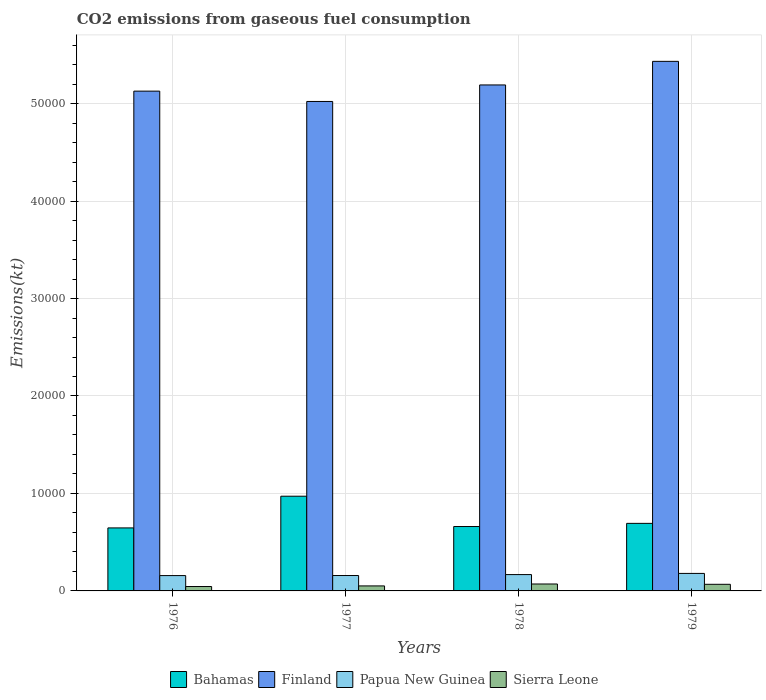How many different coloured bars are there?
Your answer should be very brief. 4. How many groups of bars are there?
Make the answer very short. 4. Are the number of bars per tick equal to the number of legend labels?
Your answer should be compact. Yes. Are the number of bars on each tick of the X-axis equal?
Offer a terse response. Yes. How many bars are there on the 2nd tick from the right?
Keep it short and to the point. 4. In how many cases, is the number of bars for a given year not equal to the number of legend labels?
Provide a short and direct response. 0. What is the amount of CO2 emitted in Bahamas in 1977?
Make the answer very short. 9717.55. Across all years, what is the maximum amount of CO2 emitted in Bahamas?
Your response must be concise. 9717.55. Across all years, what is the minimum amount of CO2 emitted in Finland?
Your answer should be compact. 5.02e+04. In which year was the amount of CO2 emitted in Papua New Guinea maximum?
Offer a terse response. 1979. In which year was the amount of CO2 emitted in Finland minimum?
Give a very brief answer. 1977. What is the total amount of CO2 emitted in Sierra Leone in the graph?
Ensure brevity in your answer.  2354.21. What is the difference between the amount of CO2 emitted in Bahamas in 1977 and that in 1979?
Your answer should be compact. 2786.92. What is the difference between the amount of CO2 emitted in Bahamas in 1977 and the amount of CO2 emitted in Papua New Guinea in 1979?
Provide a short and direct response. 7920.72. What is the average amount of CO2 emitted in Sierra Leone per year?
Keep it short and to the point. 588.55. In the year 1977, what is the difference between the amount of CO2 emitted in Papua New Guinea and amount of CO2 emitted in Sierra Leone?
Offer a very short reply. 1067.1. In how many years, is the amount of CO2 emitted in Bahamas greater than 6000 kt?
Provide a short and direct response. 4. What is the ratio of the amount of CO2 emitted in Papua New Guinea in 1976 to that in 1979?
Your response must be concise. 0.88. Is the amount of CO2 emitted in Bahamas in 1976 less than that in 1979?
Give a very brief answer. Yes. Is the difference between the amount of CO2 emitted in Papua New Guinea in 1976 and 1979 greater than the difference between the amount of CO2 emitted in Sierra Leone in 1976 and 1979?
Provide a short and direct response. Yes. What is the difference between the highest and the second highest amount of CO2 emitted in Bahamas?
Give a very brief answer. 2786.92. What is the difference between the highest and the lowest amount of CO2 emitted in Finland?
Your response must be concise. 4114.37. Is the sum of the amount of CO2 emitted in Bahamas in 1976 and 1978 greater than the maximum amount of CO2 emitted in Papua New Guinea across all years?
Keep it short and to the point. Yes. Is it the case that in every year, the sum of the amount of CO2 emitted in Finland and amount of CO2 emitted in Papua New Guinea is greater than the sum of amount of CO2 emitted in Sierra Leone and amount of CO2 emitted in Bahamas?
Make the answer very short. Yes. What does the 4th bar from the left in 1978 represents?
Keep it short and to the point. Sierra Leone. What does the 1st bar from the right in 1976 represents?
Offer a terse response. Sierra Leone. What is the difference between two consecutive major ticks on the Y-axis?
Your answer should be very brief. 10000. Are the values on the major ticks of Y-axis written in scientific E-notation?
Keep it short and to the point. No. Does the graph contain any zero values?
Offer a very short reply. No. Where does the legend appear in the graph?
Provide a succinct answer. Bottom center. What is the title of the graph?
Offer a terse response. CO2 emissions from gaseous fuel consumption. Does "Venezuela" appear as one of the legend labels in the graph?
Keep it short and to the point. No. What is the label or title of the X-axis?
Your answer should be very brief. Years. What is the label or title of the Y-axis?
Keep it short and to the point. Emissions(kt). What is the Emissions(kt) in Bahamas in 1976?
Provide a succinct answer. 6464.92. What is the Emissions(kt) in Finland in 1976?
Your answer should be compact. 5.13e+04. What is the Emissions(kt) in Papua New Guinea in 1976?
Provide a short and direct response. 1573.14. What is the Emissions(kt) in Sierra Leone in 1976?
Your response must be concise. 451.04. What is the Emissions(kt) of Bahamas in 1977?
Give a very brief answer. 9717.55. What is the Emissions(kt) of Finland in 1977?
Your response must be concise. 5.02e+04. What is the Emissions(kt) in Papua New Guinea in 1977?
Offer a very short reply. 1580.48. What is the Emissions(kt) of Sierra Leone in 1977?
Give a very brief answer. 513.38. What is the Emissions(kt) of Bahamas in 1978?
Your answer should be very brief. 6607.93. What is the Emissions(kt) of Finland in 1978?
Offer a very short reply. 5.19e+04. What is the Emissions(kt) of Papua New Guinea in 1978?
Offer a terse response. 1675.82. What is the Emissions(kt) in Sierra Leone in 1978?
Provide a succinct answer. 711.4. What is the Emissions(kt) in Bahamas in 1979?
Provide a short and direct response. 6930.63. What is the Emissions(kt) in Finland in 1979?
Your answer should be very brief. 5.43e+04. What is the Emissions(kt) of Papua New Guinea in 1979?
Your answer should be very brief. 1796.83. What is the Emissions(kt) of Sierra Leone in 1979?
Your answer should be very brief. 678.39. Across all years, what is the maximum Emissions(kt) in Bahamas?
Your answer should be very brief. 9717.55. Across all years, what is the maximum Emissions(kt) in Finland?
Provide a succinct answer. 5.43e+04. Across all years, what is the maximum Emissions(kt) in Papua New Guinea?
Your answer should be compact. 1796.83. Across all years, what is the maximum Emissions(kt) of Sierra Leone?
Provide a short and direct response. 711.4. Across all years, what is the minimum Emissions(kt) in Bahamas?
Your response must be concise. 6464.92. Across all years, what is the minimum Emissions(kt) in Finland?
Give a very brief answer. 5.02e+04. Across all years, what is the minimum Emissions(kt) of Papua New Guinea?
Keep it short and to the point. 1573.14. Across all years, what is the minimum Emissions(kt) of Sierra Leone?
Make the answer very short. 451.04. What is the total Emissions(kt) of Bahamas in the graph?
Provide a short and direct response. 2.97e+04. What is the total Emissions(kt) in Finland in the graph?
Your answer should be very brief. 2.08e+05. What is the total Emissions(kt) in Papua New Guinea in the graph?
Keep it short and to the point. 6626.27. What is the total Emissions(kt) in Sierra Leone in the graph?
Your answer should be compact. 2354.21. What is the difference between the Emissions(kt) of Bahamas in 1976 and that in 1977?
Provide a succinct answer. -3252.63. What is the difference between the Emissions(kt) in Finland in 1976 and that in 1977?
Make the answer very short. 1059.76. What is the difference between the Emissions(kt) in Papua New Guinea in 1976 and that in 1977?
Offer a terse response. -7.33. What is the difference between the Emissions(kt) in Sierra Leone in 1976 and that in 1977?
Keep it short and to the point. -62.34. What is the difference between the Emissions(kt) of Bahamas in 1976 and that in 1978?
Make the answer very short. -143.01. What is the difference between the Emissions(kt) of Finland in 1976 and that in 1978?
Provide a succinct answer. -634.39. What is the difference between the Emissions(kt) in Papua New Guinea in 1976 and that in 1978?
Ensure brevity in your answer.  -102.68. What is the difference between the Emissions(kt) of Sierra Leone in 1976 and that in 1978?
Ensure brevity in your answer.  -260.36. What is the difference between the Emissions(kt) of Bahamas in 1976 and that in 1979?
Provide a succinct answer. -465.71. What is the difference between the Emissions(kt) of Finland in 1976 and that in 1979?
Your answer should be very brief. -3054.61. What is the difference between the Emissions(kt) in Papua New Guinea in 1976 and that in 1979?
Provide a short and direct response. -223.69. What is the difference between the Emissions(kt) of Sierra Leone in 1976 and that in 1979?
Provide a short and direct response. -227.35. What is the difference between the Emissions(kt) of Bahamas in 1977 and that in 1978?
Make the answer very short. 3109.62. What is the difference between the Emissions(kt) in Finland in 1977 and that in 1978?
Your response must be concise. -1694.15. What is the difference between the Emissions(kt) in Papua New Guinea in 1977 and that in 1978?
Your answer should be very brief. -95.34. What is the difference between the Emissions(kt) of Sierra Leone in 1977 and that in 1978?
Your answer should be compact. -198.02. What is the difference between the Emissions(kt) in Bahamas in 1977 and that in 1979?
Your answer should be very brief. 2786.92. What is the difference between the Emissions(kt) of Finland in 1977 and that in 1979?
Make the answer very short. -4114.37. What is the difference between the Emissions(kt) in Papua New Guinea in 1977 and that in 1979?
Ensure brevity in your answer.  -216.35. What is the difference between the Emissions(kt) in Sierra Leone in 1977 and that in 1979?
Provide a succinct answer. -165.01. What is the difference between the Emissions(kt) in Bahamas in 1978 and that in 1979?
Keep it short and to the point. -322.7. What is the difference between the Emissions(kt) in Finland in 1978 and that in 1979?
Offer a terse response. -2420.22. What is the difference between the Emissions(kt) of Papua New Guinea in 1978 and that in 1979?
Offer a very short reply. -121.01. What is the difference between the Emissions(kt) in Sierra Leone in 1978 and that in 1979?
Keep it short and to the point. 33. What is the difference between the Emissions(kt) in Bahamas in 1976 and the Emissions(kt) in Finland in 1977?
Offer a terse response. -4.38e+04. What is the difference between the Emissions(kt) in Bahamas in 1976 and the Emissions(kt) in Papua New Guinea in 1977?
Keep it short and to the point. 4884.44. What is the difference between the Emissions(kt) of Bahamas in 1976 and the Emissions(kt) of Sierra Leone in 1977?
Provide a succinct answer. 5951.54. What is the difference between the Emissions(kt) in Finland in 1976 and the Emissions(kt) in Papua New Guinea in 1977?
Your answer should be very brief. 4.97e+04. What is the difference between the Emissions(kt) in Finland in 1976 and the Emissions(kt) in Sierra Leone in 1977?
Provide a short and direct response. 5.08e+04. What is the difference between the Emissions(kt) in Papua New Guinea in 1976 and the Emissions(kt) in Sierra Leone in 1977?
Give a very brief answer. 1059.76. What is the difference between the Emissions(kt) in Bahamas in 1976 and the Emissions(kt) in Finland in 1978?
Provide a succinct answer. -4.54e+04. What is the difference between the Emissions(kt) in Bahamas in 1976 and the Emissions(kt) in Papua New Guinea in 1978?
Your response must be concise. 4789.1. What is the difference between the Emissions(kt) in Bahamas in 1976 and the Emissions(kt) in Sierra Leone in 1978?
Give a very brief answer. 5753.52. What is the difference between the Emissions(kt) of Finland in 1976 and the Emissions(kt) of Papua New Guinea in 1978?
Provide a succinct answer. 4.96e+04. What is the difference between the Emissions(kt) in Finland in 1976 and the Emissions(kt) in Sierra Leone in 1978?
Provide a succinct answer. 5.06e+04. What is the difference between the Emissions(kt) in Papua New Guinea in 1976 and the Emissions(kt) in Sierra Leone in 1978?
Offer a very short reply. 861.75. What is the difference between the Emissions(kt) of Bahamas in 1976 and the Emissions(kt) of Finland in 1979?
Offer a very short reply. -4.79e+04. What is the difference between the Emissions(kt) in Bahamas in 1976 and the Emissions(kt) in Papua New Guinea in 1979?
Provide a succinct answer. 4668.09. What is the difference between the Emissions(kt) of Bahamas in 1976 and the Emissions(kt) of Sierra Leone in 1979?
Offer a very short reply. 5786.53. What is the difference between the Emissions(kt) of Finland in 1976 and the Emissions(kt) of Papua New Guinea in 1979?
Offer a terse response. 4.95e+04. What is the difference between the Emissions(kt) in Finland in 1976 and the Emissions(kt) in Sierra Leone in 1979?
Offer a very short reply. 5.06e+04. What is the difference between the Emissions(kt) in Papua New Guinea in 1976 and the Emissions(kt) in Sierra Leone in 1979?
Give a very brief answer. 894.75. What is the difference between the Emissions(kt) of Bahamas in 1977 and the Emissions(kt) of Finland in 1978?
Your answer should be compact. -4.22e+04. What is the difference between the Emissions(kt) in Bahamas in 1977 and the Emissions(kt) in Papua New Guinea in 1978?
Provide a short and direct response. 8041.73. What is the difference between the Emissions(kt) of Bahamas in 1977 and the Emissions(kt) of Sierra Leone in 1978?
Your response must be concise. 9006.15. What is the difference between the Emissions(kt) of Finland in 1977 and the Emissions(kt) of Papua New Guinea in 1978?
Offer a terse response. 4.85e+04. What is the difference between the Emissions(kt) of Finland in 1977 and the Emissions(kt) of Sierra Leone in 1978?
Your answer should be very brief. 4.95e+04. What is the difference between the Emissions(kt) in Papua New Guinea in 1977 and the Emissions(kt) in Sierra Leone in 1978?
Your response must be concise. 869.08. What is the difference between the Emissions(kt) of Bahamas in 1977 and the Emissions(kt) of Finland in 1979?
Give a very brief answer. -4.46e+04. What is the difference between the Emissions(kt) in Bahamas in 1977 and the Emissions(kt) in Papua New Guinea in 1979?
Your response must be concise. 7920.72. What is the difference between the Emissions(kt) of Bahamas in 1977 and the Emissions(kt) of Sierra Leone in 1979?
Your answer should be compact. 9039.16. What is the difference between the Emissions(kt) of Finland in 1977 and the Emissions(kt) of Papua New Guinea in 1979?
Give a very brief answer. 4.84e+04. What is the difference between the Emissions(kt) of Finland in 1977 and the Emissions(kt) of Sierra Leone in 1979?
Your answer should be compact. 4.95e+04. What is the difference between the Emissions(kt) in Papua New Guinea in 1977 and the Emissions(kt) in Sierra Leone in 1979?
Your answer should be compact. 902.08. What is the difference between the Emissions(kt) of Bahamas in 1978 and the Emissions(kt) of Finland in 1979?
Offer a terse response. -4.77e+04. What is the difference between the Emissions(kt) of Bahamas in 1978 and the Emissions(kt) of Papua New Guinea in 1979?
Your response must be concise. 4811.1. What is the difference between the Emissions(kt) in Bahamas in 1978 and the Emissions(kt) in Sierra Leone in 1979?
Your response must be concise. 5929.54. What is the difference between the Emissions(kt) of Finland in 1978 and the Emissions(kt) of Papua New Guinea in 1979?
Offer a terse response. 5.01e+04. What is the difference between the Emissions(kt) of Finland in 1978 and the Emissions(kt) of Sierra Leone in 1979?
Offer a very short reply. 5.12e+04. What is the difference between the Emissions(kt) of Papua New Guinea in 1978 and the Emissions(kt) of Sierra Leone in 1979?
Your response must be concise. 997.42. What is the average Emissions(kt) of Bahamas per year?
Offer a terse response. 7430.26. What is the average Emissions(kt) of Finland per year?
Make the answer very short. 5.19e+04. What is the average Emissions(kt) of Papua New Guinea per year?
Your answer should be compact. 1656.57. What is the average Emissions(kt) of Sierra Leone per year?
Your answer should be very brief. 588.55. In the year 1976, what is the difference between the Emissions(kt) of Bahamas and Emissions(kt) of Finland?
Offer a terse response. -4.48e+04. In the year 1976, what is the difference between the Emissions(kt) in Bahamas and Emissions(kt) in Papua New Guinea?
Ensure brevity in your answer.  4891.78. In the year 1976, what is the difference between the Emissions(kt) in Bahamas and Emissions(kt) in Sierra Leone?
Your answer should be very brief. 6013.88. In the year 1976, what is the difference between the Emissions(kt) of Finland and Emissions(kt) of Papua New Guinea?
Your answer should be compact. 4.97e+04. In the year 1976, what is the difference between the Emissions(kt) of Finland and Emissions(kt) of Sierra Leone?
Your response must be concise. 5.08e+04. In the year 1976, what is the difference between the Emissions(kt) in Papua New Guinea and Emissions(kt) in Sierra Leone?
Keep it short and to the point. 1122.1. In the year 1977, what is the difference between the Emissions(kt) of Bahamas and Emissions(kt) of Finland?
Your answer should be very brief. -4.05e+04. In the year 1977, what is the difference between the Emissions(kt) of Bahamas and Emissions(kt) of Papua New Guinea?
Make the answer very short. 8137.07. In the year 1977, what is the difference between the Emissions(kt) in Bahamas and Emissions(kt) in Sierra Leone?
Your answer should be compact. 9204.17. In the year 1977, what is the difference between the Emissions(kt) of Finland and Emissions(kt) of Papua New Guinea?
Keep it short and to the point. 4.86e+04. In the year 1977, what is the difference between the Emissions(kt) in Finland and Emissions(kt) in Sierra Leone?
Provide a succinct answer. 4.97e+04. In the year 1977, what is the difference between the Emissions(kt) of Papua New Guinea and Emissions(kt) of Sierra Leone?
Ensure brevity in your answer.  1067.1. In the year 1978, what is the difference between the Emissions(kt) of Bahamas and Emissions(kt) of Finland?
Give a very brief answer. -4.53e+04. In the year 1978, what is the difference between the Emissions(kt) in Bahamas and Emissions(kt) in Papua New Guinea?
Your answer should be compact. 4932.11. In the year 1978, what is the difference between the Emissions(kt) in Bahamas and Emissions(kt) in Sierra Leone?
Make the answer very short. 5896.54. In the year 1978, what is the difference between the Emissions(kt) in Finland and Emissions(kt) in Papua New Guinea?
Keep it short and to the point. 5.02e+04. In the year 1978, what is the difference between the Emissions(kt) in Finland and Emissions(kt) in Sierra Leone?
Your answer should be compact. 5.12e+04. In the year 1978, what is the difference between the Emissions(kt) in Papua New Guinea and Emissions(kt) in Sierra Leone?
Offer a very short reply. 964.42. In the year 1979, what is the difference between the Emissions(kt) in Bahamas and Emissions(kt) in Finland?
Offer a very short reply. -4.74e+04. In the year 1979, what is the difference between the Emissions(kt) of Bahamas and Emissions(kt) of Papua New Guinea?
Make the answer very short. 5133.8. In the year 1979, what is the difference between the Emissions(kt) of Bahamas and Emissions(kt) of Sierra Leone?
Your response must be concise. 6252.23. In the year 1979, what is the difference between the Emissions(kt) of Finland and Emissions(kt) of Papua New Guinea?
Make the answer very short. 5.25e+04. In the year 1979, what is the difference between the Emissions(kt) of Finland and Emissions(kt) of Sierra Leone?
Your answer should be very brief. 5.37e+04. In the year 1979, what is the difference between the Emissions(kt) of Papua New Guinea and Emissions(kt) of Sierra Leone?
Ensure brevity in your answer.  1118.43. What is the ratio of the Emissions(kt) in Bahamas in 1976 to that in 1977?
Offer a terse response. 0.67. What is the ratio of the Emissions(kt) of Finland in 1976 to that in 1977?
Provide a succinct answer. 1.02. What is the ratio of the Emissions(kt) of Papua New Guinea in 1976 to that in 1977?
Provide a succinct answer. 1. What is the ratio of the Emissions(kt) of Sierra Leone in 1976 to that in 1977?
Offer a terse response. 0.88. What is the ratio of the Emissions(kt) of Bahamas in 1976 to that in 1978?
Offer a terse response. 0.98. What is the ratio of the Emissions(kt) in Papua New Guinea in 1976 to that in 1978?
Provide a short and direct response. 0.94. What is the ratio of the Emissions(kt) of Sierra Leone in 1976 to that in 1978?
Offer a terse response. 0.63. What is the ratio of the Emissions(kt) of Bahamas in 1976 to that in 1979?
Make the answer very short. 0.93. What is the ratio of the Emissions(kt) of Finland in 1976 to that in 1979?
Your answer should be compact. 0.94. What is the ratio of the Emissions(kt) in Papua New Guinea in 1976 to that in 1979?
Provide a short and direct response. 0.88. What is the ratio of the Emissions(kt) in Sierra Leone in 1976 to that in 1979?
Offer a very short reply. 0.66. What is the ratio of the Emissions(kt) of Bahamas in 1977 to that in 1978?
Your response must be concise. 1.47. What is the ratio of the Emissions(kt) of Finland in 1977 to that in 1978?
Keep it short and to the point. 0.97. What is the ratio of the Emissions(kt) of Papua New Guinea in 1977 to that in 1978?
Provide a succinct answer. 0.94. What is the ratio of the Emissions(kt) of Sierra Leone in 1977 to that in 1978?
Offer a very short reply. 0.72. What is the ratio of the Emissions(kt) in Bahamas in 1977 to that in 1979?
Your response must be concise. 1.4. What is the ratio of the Emissions(kt) of Finland in 1977 to that in 1979?
Offer a terse response. 0.92. What is the ratio of the Emissions(kt) of Papua New Guinea in 1977 to that in 1979?
Give a very brief answer. 0.88. What is the ratio of the Emissions(kt) in Sierra Leone in 1977 to that in 1979?
Make the answer very short. 0.76. What is the ratio of the Emissions(kt) in Bahamas in 1978 to that in 1979?
Make the answer very short. 0.95. What is the ratio of the Emissions(kt) in Finland in 1978 to that in 1979?
Your response must be concise. 0.96. What is the ratio of the Emissions(kt) of Papua New Guinea in 1978 to that in 1979?
Offer a very short reply. 0.93. What is the ratio of the Emissions(kt) in Sierra Leone in 1978 to that in 1979?
Give a very brief answer. 1.05. What is the difference between the highest and the second highest Emissions(kt) in Bahamas?
Your answer should be compact. 2786.92. What is the difference between the highest and the second highest Emissions(kt) in Finland?
Provide a short and direct response. 2420.22. What is the difference between the highest and the second highest Emissions(kt) in Papua New Guinea?
Give a very brief answer. 121.01. What is the difference between the highest and the second highest Emissions(kt) of Sierra Leone?
Make the answer very short. 33. What is the difference between the highest and the lowest Emissions(kt) in Bahamas?
Make the answer very short. 3252.63. What is the difference between the highest and the lowest Emissions(kt) of Finland?
Provide a succinct answer. 4114.37. What is the difference between the highest and the lowest Emissions(kt) in Papua New Guinea?
Your answer should be compact. 223.69. What is the difference between the highest and the lowest Emissions(kt) in Sierra Leone?
Your answer should be very brief. 260.36. 